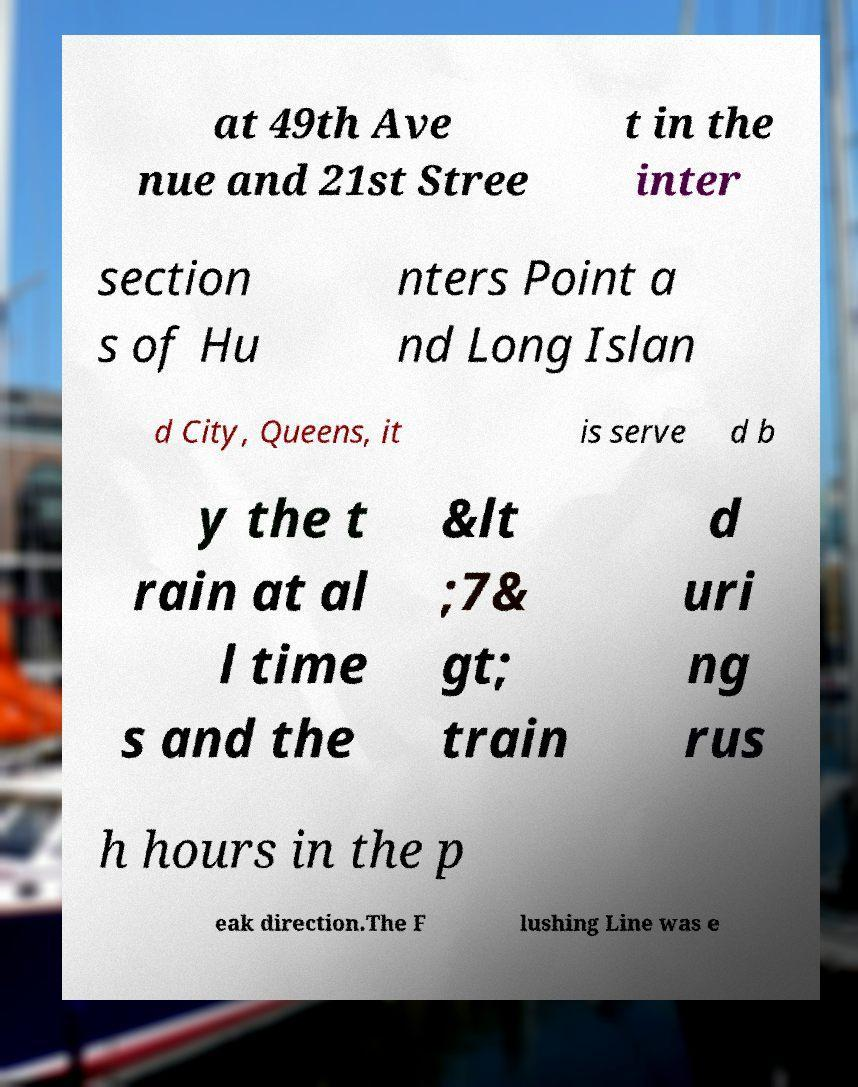Could you extract and type out the text from this image? at 49th Ave nue and 21st Stree t in the inter section s of Hu nters Point a nd Long Islan d City, Queens, it is serve d b y the t rain at al l time s and the &lt ;7& gt; train d uri ng rus h hours in the p eak direction.The F lushing Line was e 